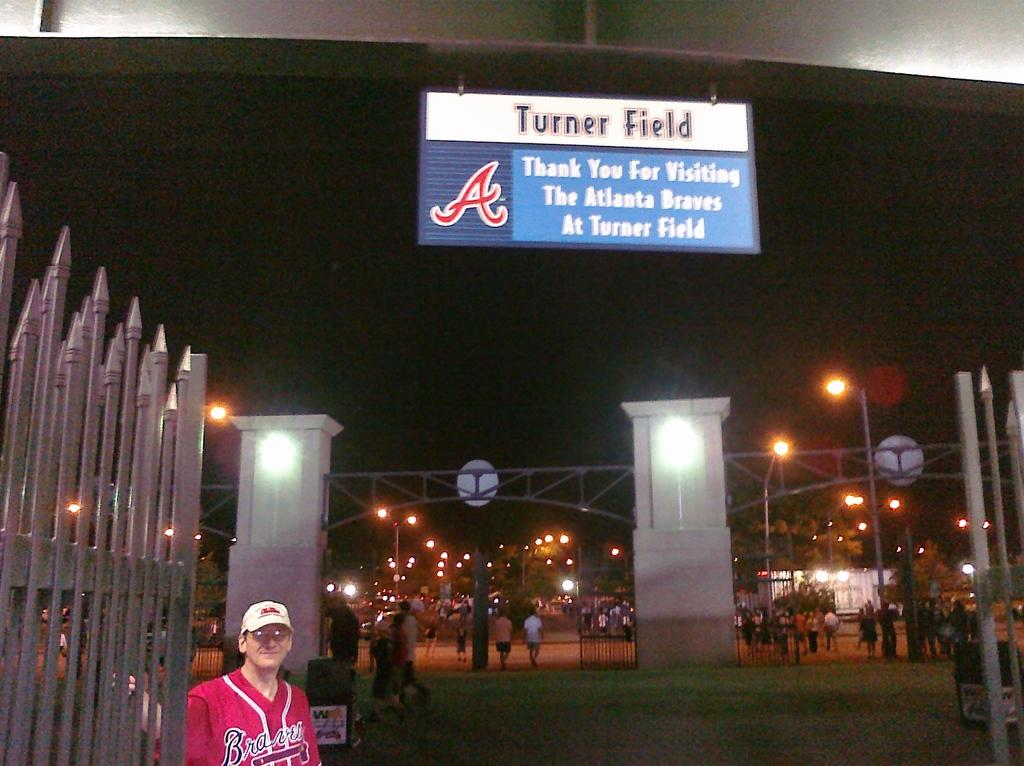<image>
Offer a succinct explanation of the picture presented. A man in a Braves jersey stands over a sign reading Turner Field. 